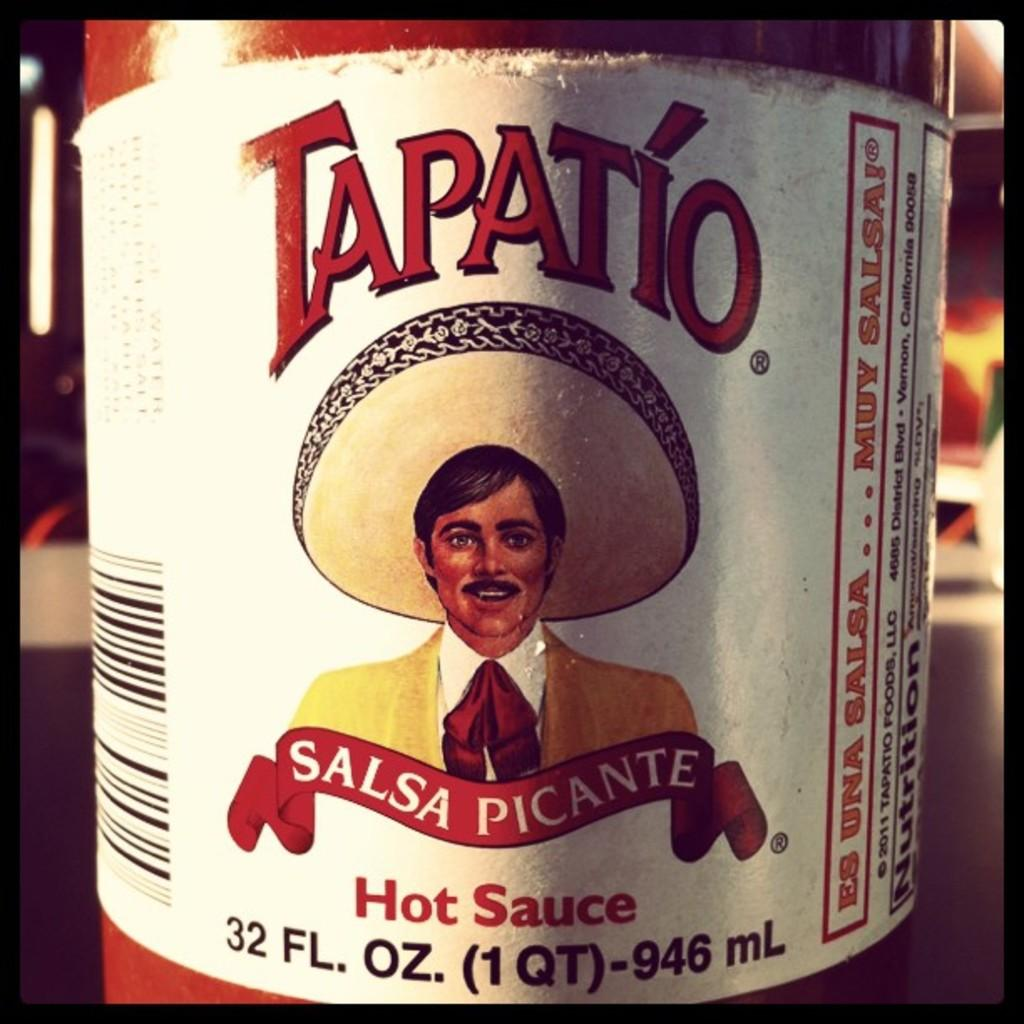What object is visible in the image that contains sauce? There is a sauce bottle in the image. Where is the sauce bottle located? The sauce bottle is placed on a table. What feature does the sauce bottle have? The sauce bottle has a cover on it. What can be seen on the sauce bottle? The sauce bottle has a name on it. What type of outdoor space is visible in the image? There is a patio visible in the image. What is under the patio in the image? There is a man's image under the patio. How many cows are visible in the image? There are no cows present in the image. What is the moon doing in the image? The moon is not visible in the image. 